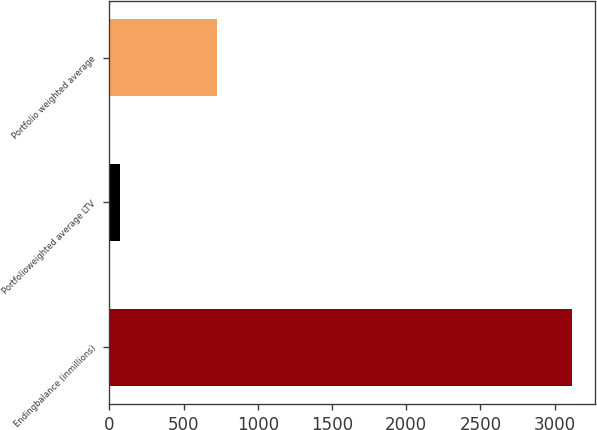Convert chart to OTSL. <chart><loc_0><loc_0><loc_500><loc_500><bar_chart><fcel>Endingbalance (inmillions)<fcel>Portfolioweighted average LTV<fcel>Portfolio weighted average<nl><fcel>3116<fcel>70<fcel>725<nl></chart> 